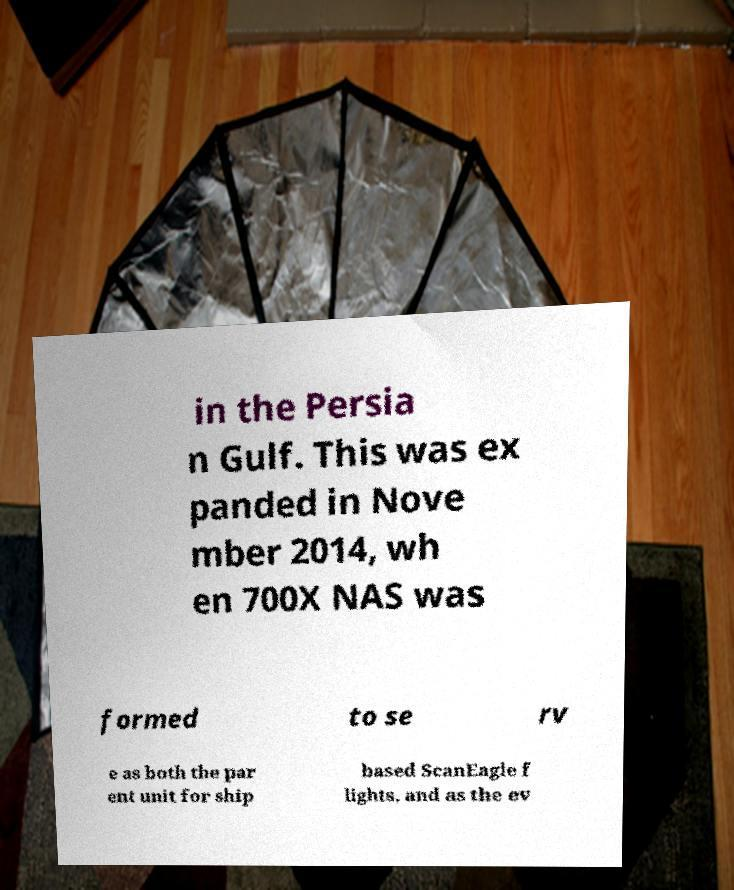For documentation purposes, I need the text within this image transcribed. Could you provide that? in the Persia n Gulf. This was ex panded in Nove mber 2014, wh en 700X NAS was formed to se rv e as both the par ent unit for ship based ScanEagle f lights, and as the ev 